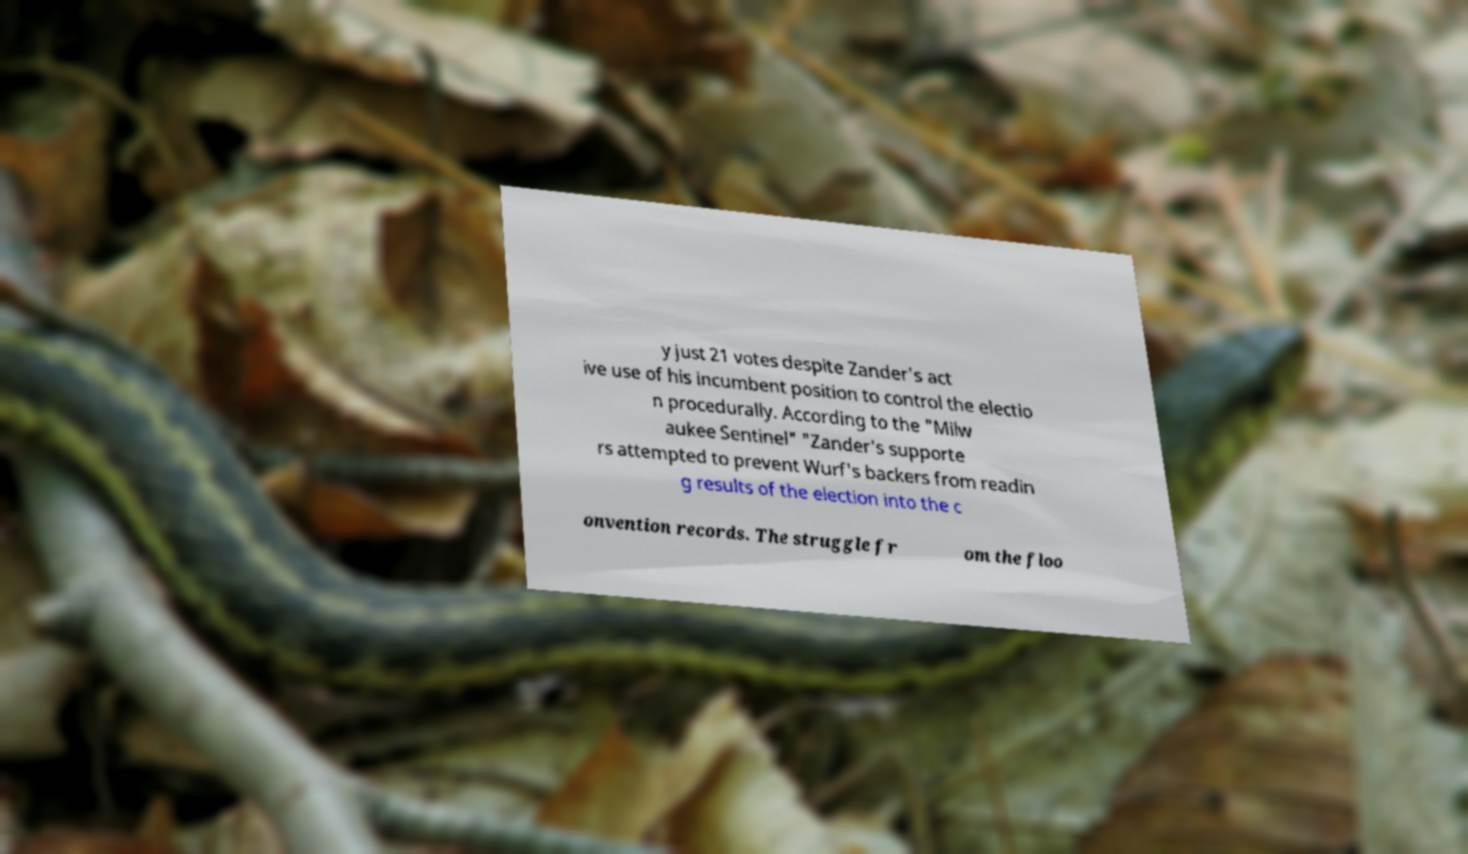Please identify and transcribe the text found in this image. y just 21 votes despite Zander's act ive use of his incumbent position to control the electio n procedurally. According to the "Milw aukee Sentinel" "Zander's supporte rs attempted to prevent Wurf's backers from readin g results of the election into the c onvention records. The struggle fr om the floo 